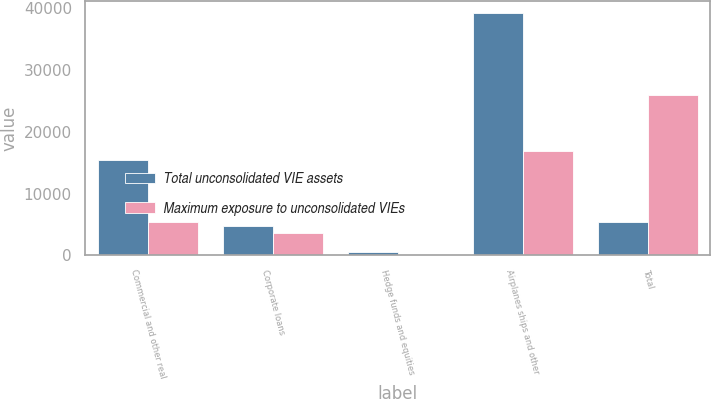Convert chart. <chart><loc_0><loc_0><loc_500><loc_500><stacked_bar_chart><ecel><fcel>Commercial and other real<fcel>Corporate loans<fcel>Hedge funds and equities<fcel>Airplanes ships and other<fcel>Total<nl><fcel>Total unconsolidated VIE assets<fcel>15370<fcel>4725<fcel>542<fcel>39202<fcel>5445<nl><fcel>Maximum exposure to unconsolidated VIEs<fcel>5445<fcel>3587<fcel>58<fcel>16849<fcel>25939<nl></chart> 